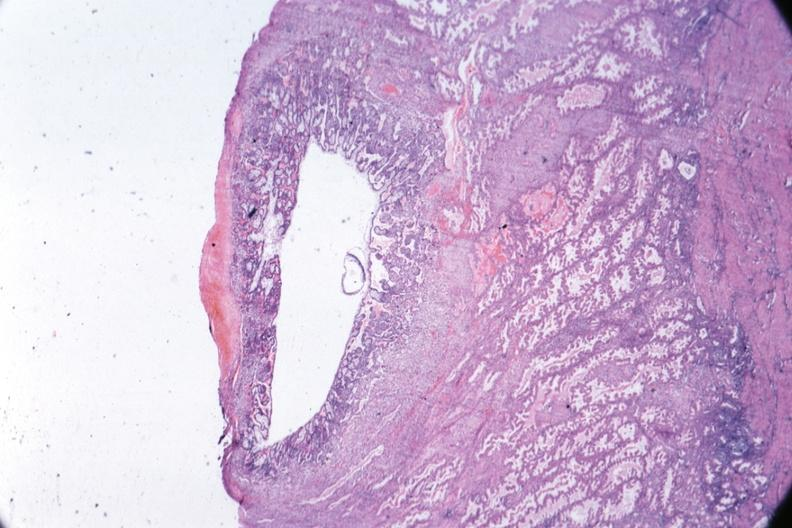s female reproductive present?
Answer the question using a single word or phrase. Yes 